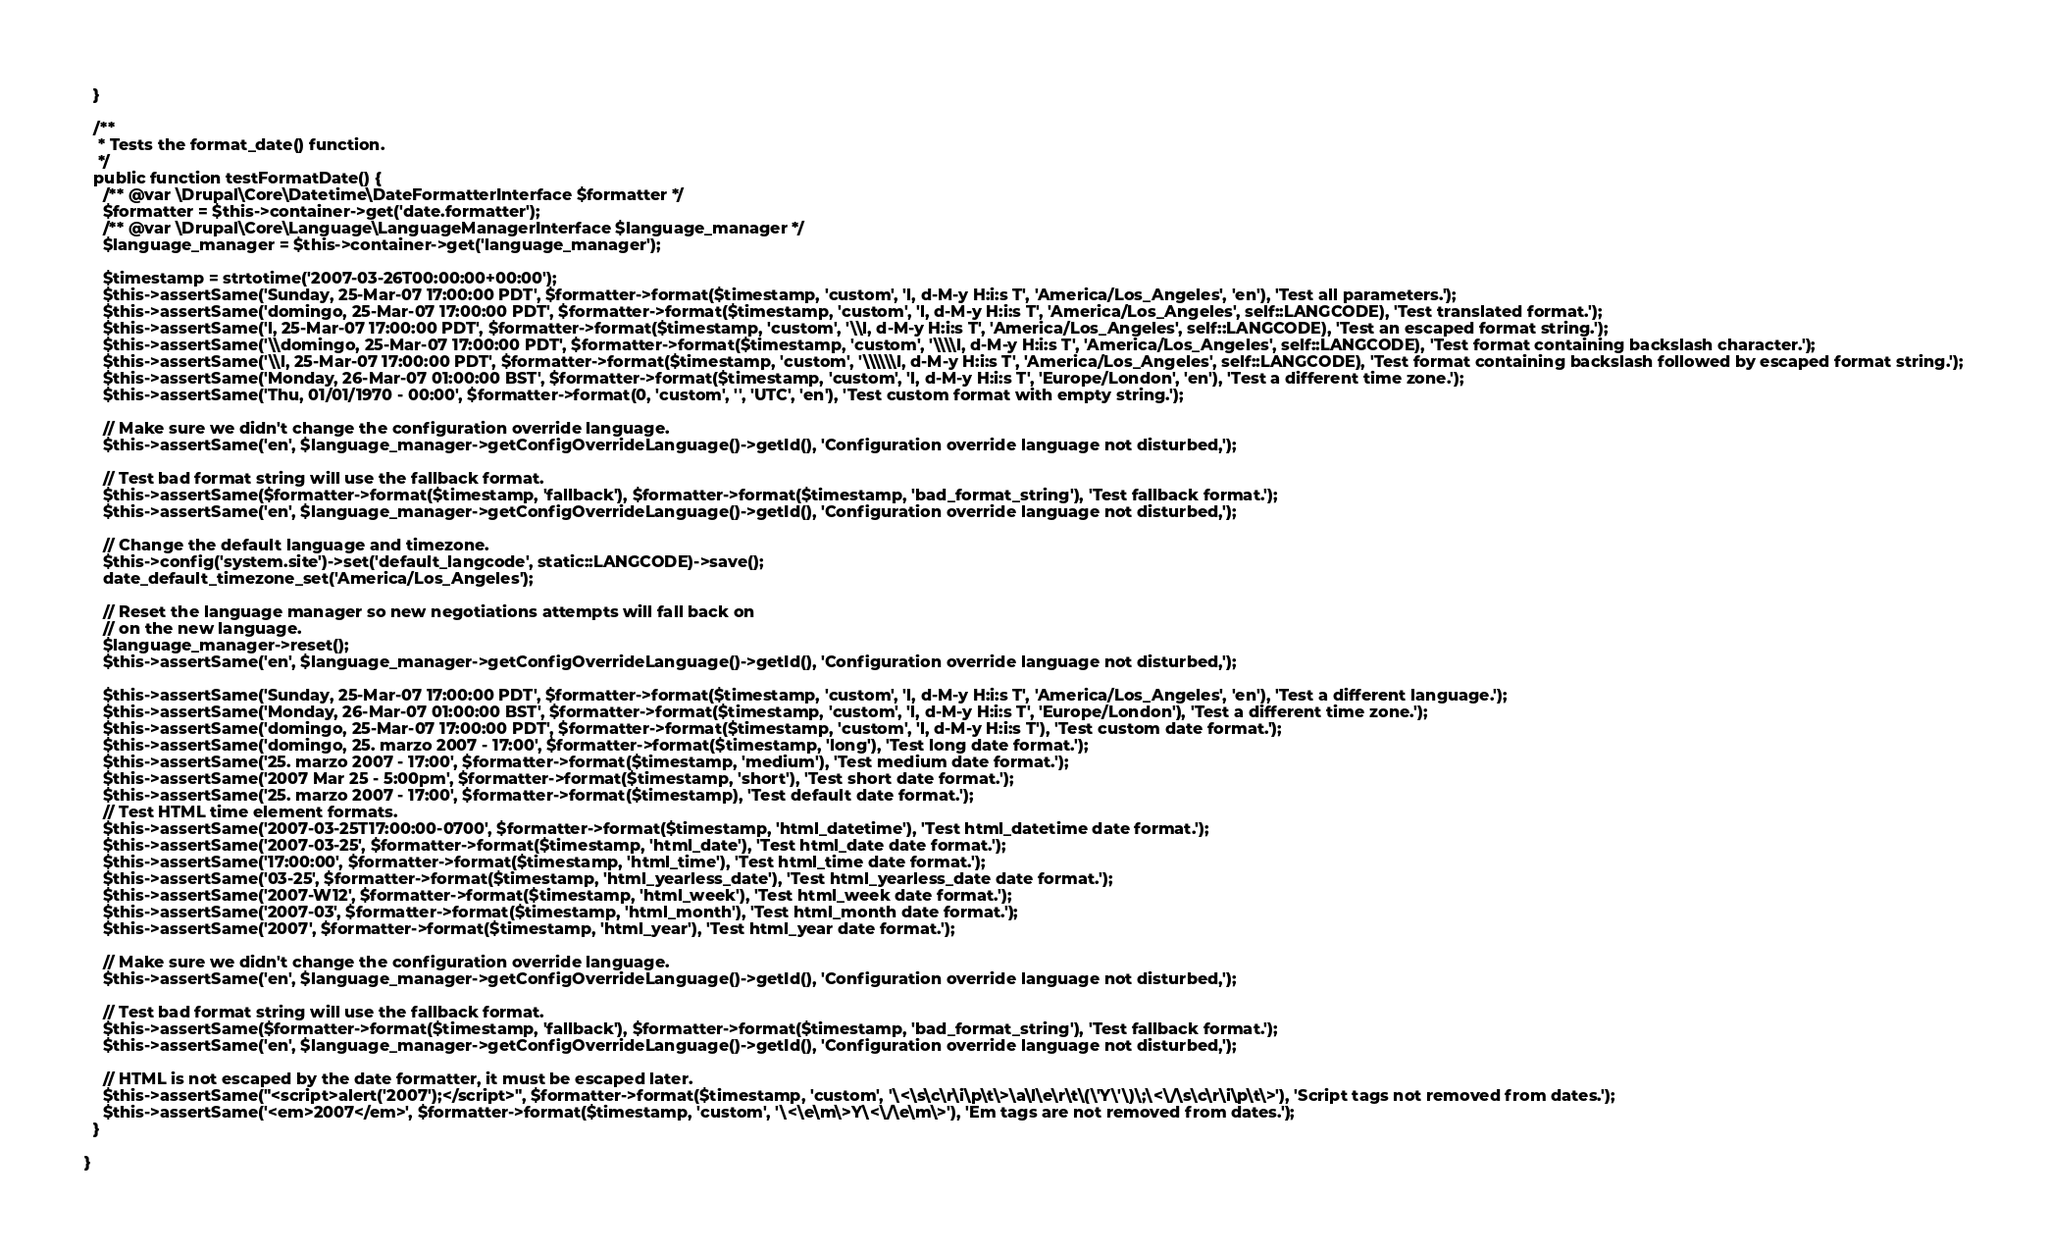Convert code to text. <code><loc_0><loc_0><loc_500><loc_500><_PHP_>  }

  /**
   * Tests the format_date() function.
   */
  public function testFormatDate() {
    /** @var \Drupal\Core\Datetime\DateFormatterInterface $formatter */
    $formatter = $this->container->get('date.formatter');
    /** @var \Drupal\Core\Language\LanguageManagerInterface $language_manager */
    $language_manager = $this->container->get('language_manager');

    $timestamp = strtotime('2007-03-26T00:00:00+00:00');
    $this->assertSame('Sunday, 25-Mar-07 17:00:00 PDT', $formatter->format($timestamp, 'custom', 'l, d-M-y H:i:s T', 'America/Los_Angeles', 'en'), 'Test all parameters.');
    $this->assertSame('domingo, 25-Mar-07 17:00:00 PDT', $formatter->format($timestamp, 'custom', 'l, d-M-y H:i:s T', 'America/Los_Angeles', self::LANGCODE), 'Test translated format.');
    $this->assertSame('l, 25-Mar-07 17:00:00 PDT', $formatter->format($timestamp, 'custom', '\\l, d-M-y H:i:s T', 'America/Los_Angeles', self::LANGCODE), 'Test an escaped format string.');
    $this->assertSame('\\domingo, 25-Mar-07 17:00:00 PDT', $formatter->format($timestamp, 'custom', '\\\\l, d-M-y H:i:s T', 'America/Los_Angeles', self::LANGCODE), 'Test format containing backslash character.');
    $this->assertSame('\\l, 25-Mar-07 17:00:00 PDT', $formatter->format($timestamp, 'custom', '\\\\\\l, d-M-y H:i:s T', 'America/Los_Angeles', self::LANGCODE), 'Test format containing backslash followed by escaped format string.');
    $this->assertSame('Monday, 26-Mar-07 01:00:00 BST', $formatter->format($timestamp, 'custom', 'l, d-M-y H:i:s T', 'Europe/London', 'en'), 'Test a different time zone.');
    $this->assertSame('Thu, 01/01/1970 - 00:00', $formatter->format(0, 'custom', '', 'UTC', 'en'), 'Test custom format with empty string.');

    // Make sure we didn't change the configuration override language.
    $this->assertSame('en', $language_manager->getConfigOverrideLanguage()->getId(), 'Configuration override language not disturbed,');

    // Test bad format string will use the fallback format.
    $this->assertSame($formatter->format($timestamp, 'fallback'), $formatter->format($timestamp, 'bad_format_string'), 'Test fallback format.');
    $this->assertSame('en', $language_manager->getConfigOverrideLanguage()->getId(), 'Configuration override language not disturbed,');

    // Change the default language and timezone.
    $this->config('system.site')->set('default_langcode', static::LANGCODE)->save();
    date_default_timezone_set('America/Los_Angeles');

    // Reset the language manager so new negotiations attempts will fall back on
    // on the new language.
    $language_manager->reset();
    $this->assertSame('en', $language_manager->getConfigOverrideLanguage()->getId(), 'Configuration override language not disturbed,');

    $this->assertSame('Sunday, 25-Mar-07 17:00:00 PDT', $formatter->format($timestamp, 'custom', 'l, d-M-y H:i:s T', 'America/Los_Angeles', 'en'), 'Test a different language.');
    $this->assertSame('Monday, 26-Mar-07 01:00:00 BST', $formatter->format($timestamp, 'custom', 'l, d-M-y H:i:s T', 'Europe/London'), 'Test a different time zone.');
    $this->assertSame('domingo, 25-Mar-07 17:00:00 PDT', $formatter->format($timestamp, 'custom', 'l, d-M-y H:i:s T'), 'Test custom date format.');
    $this->assertSame('domingo, 25. marzo 2007 - 17:00', $formatter->format($timestamp, 'long'), 'Test long date format.');
    $this->assertSame('25. marzo 2007 - 17:00', $formatter->format($timestamp, 'medium'), 'Test medium date format.');
    $this->assertSame('2007 Mar 25 - 5:00pm', $formatter->format($timestamp, 'short'), 'Test short date format.');
    $this->assertSame('25. marzo 2007 - 17:00', $formatter->format($timestamp), 'Test default date format.');
    // Test HTML time element formats.
    $this->assertSame('2007-03-25T17:00:00-0700', $formatter->format($timestamp, 'html_datetime'), 'Test html_datetime date format.');
    $this->assertSame('2007-03-25', $formatter->format($timestamp, 'html_date'), 'Test html_date date format.');
    $this->assertSame('17:00:00', $formatter->format($timestamp, 'html_time'), 'Test html_time date format.');
    $this->assertSame('03-25', $formatter->format($timestamp, 'html_yearless_date'), 'Test html_yearless_date date format.');
    $this->assertSame('2007-W12', $formatter->format($timestamp, 'html_week'), 'Test html_week date format.');
    $this->assertSame('2007-03', $formatter->format($timestamp, 'html_month'), 'Test html_month date format.');
    $this->assertSame('2007', $formatter->format($timestamp, 'html_year'), 'Test html_year date format.');

    // Make sure we didn't change the configuration override language.
    $this->assertSame('en', $language_manager->getConfigOverrideLanguage()->getId(), 'Configuration override language not disturbed,');

    // Test bad format string will use the fallback format.
    $this->assertSame($formatter->format($timestamp, 'fallback'), $formatter->format($timestamp, 'bad_format_string'), 'Test fallback format.');
    $this->assertSame('en', $language_manager->getConfigOverrideLanguage()->getId(), 'Configuration override language not disturbed,');

    // HTML is not escaped by the date formatter, it must be escaped later.
    $this->assertSame("<script>alert('2007');</script>", $formatter->format($timestamp, 'custom', '\<\s\c\r\i\p\t\>\a\l\e\r\t\(\'Y\'\)\;\<\/\s\c\r\i\p\t\>'), 'Script tags not removed from dates.');
    $this->assertSame('<em>2007</em>', $formatter->format($timestamp, 'custom', '\<\e\m\>Y\<\/\e\m\>'), 'Em tags are not removed from dates.');
  }

}
</code> 